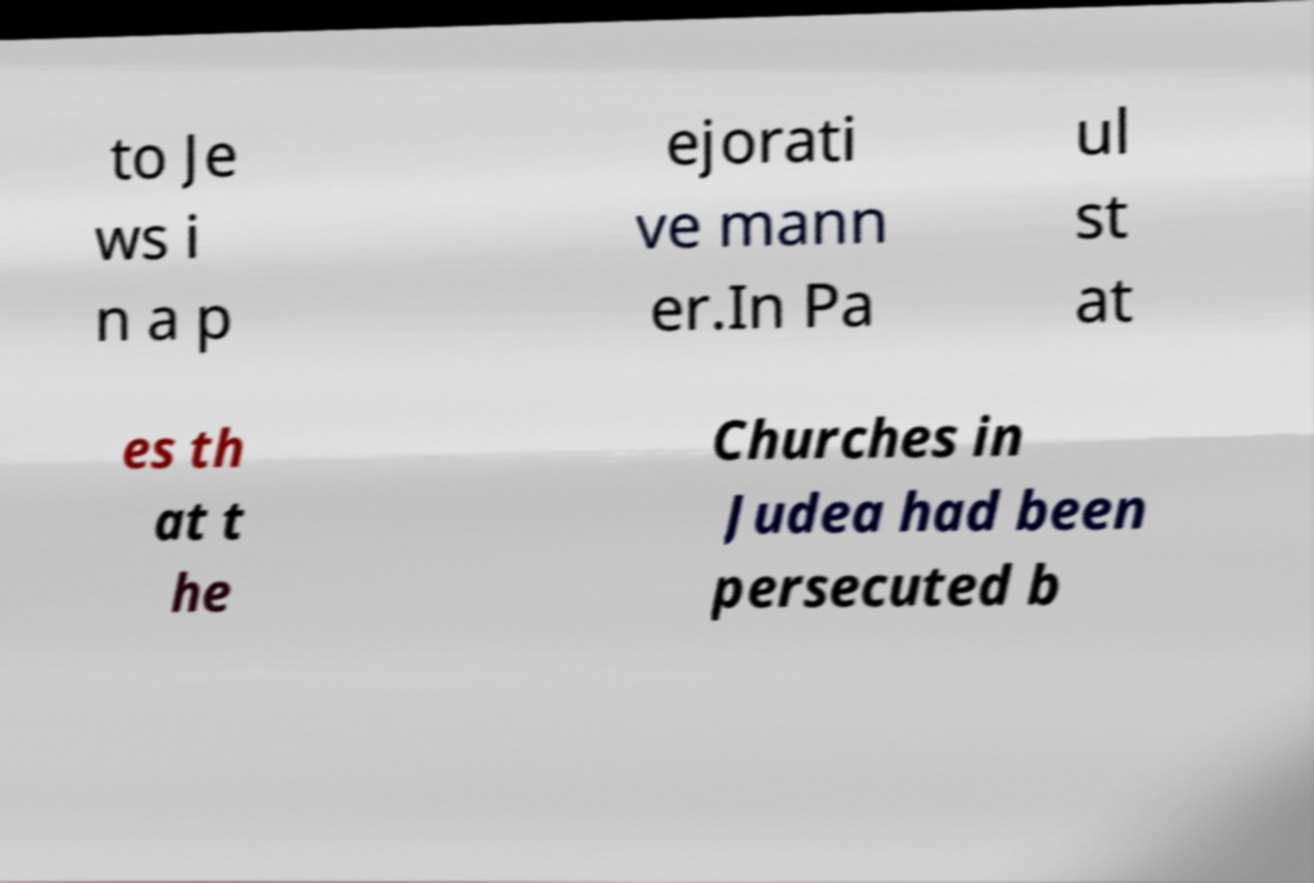For documentation purposes, I need the text within this image transcribed. Could you provide that? to Je ws i n a p ejorati ve mann er.In Pa ul st at es th at t he Churches in Judea had been persecuted b 